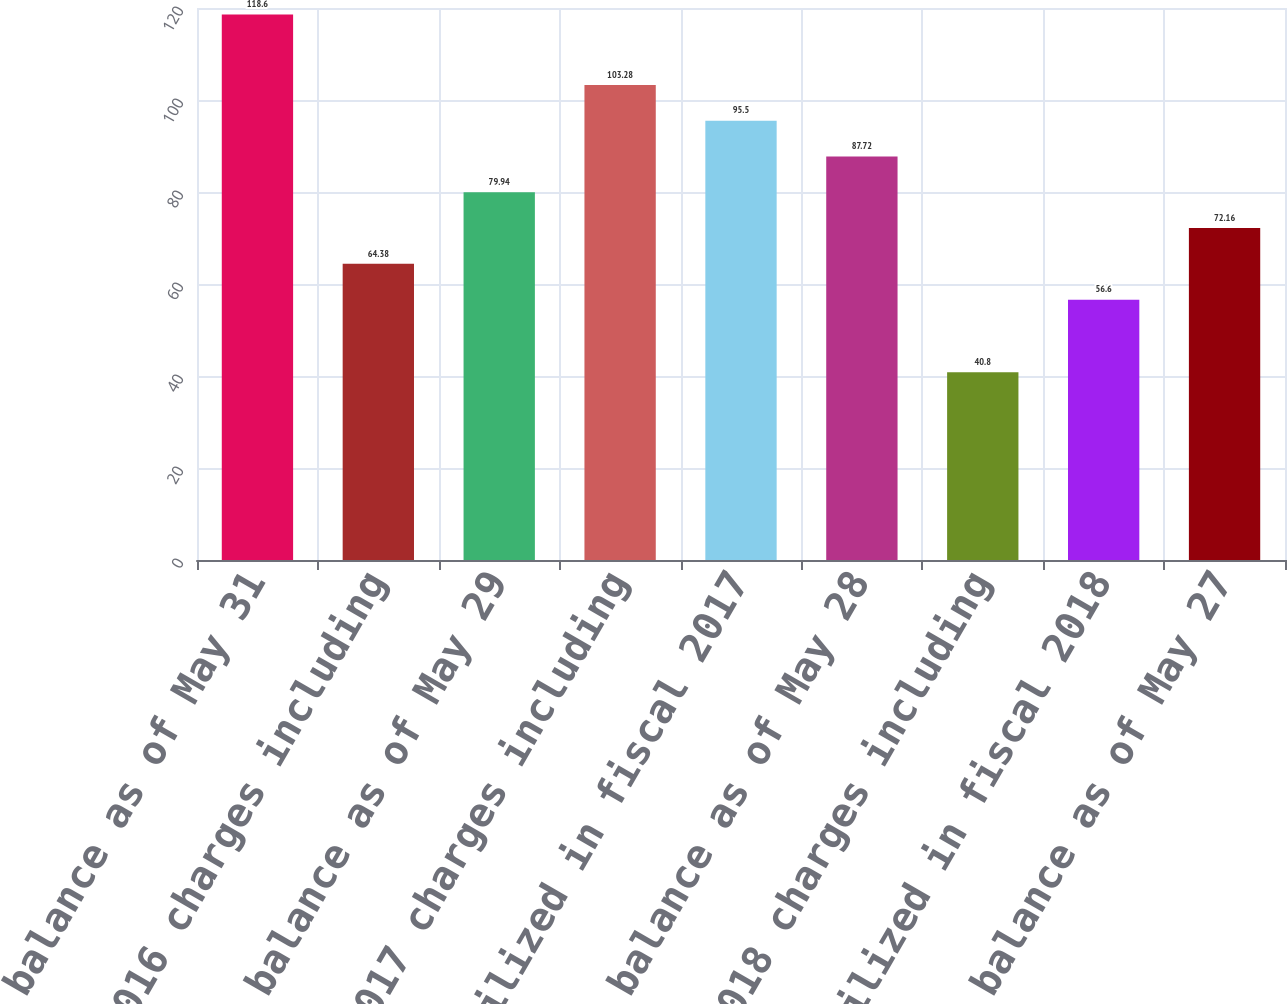Convert chart to OTSL. <chart><loc_0><loc_0><loc_500><loc_500><bar_chart><fcel>Reserve balance as of May 31<fcel>Fiscal 2016 charges including<fcel>Reserve balance as of May 29<fcel>Fiscal 2017 charges including<fcel>Utilized in fiscal 2017<fcel>Reserve balance as of May 28<fcel>Fiscal 2018 charges including<fcel>Utilized in fiscal 2018<fcel>Reserve balance as of May 27<nl><fcel>118.6<fcel>64.38<fcel>79.94<fcel>103.28<fcel>95.5<fcel>87.72<fcel>40.8<fcel>56.6<fcel>72.16<nl></chart> 